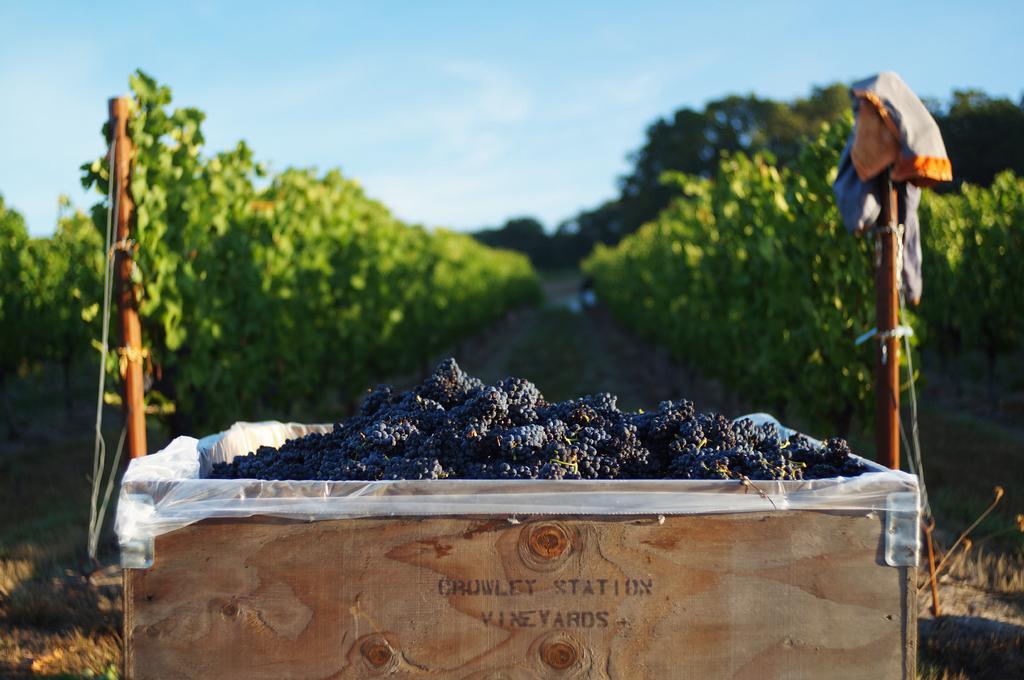Describe this image in one or two sentences. In this image we can see many grapes in a wooden box and some text is written on it, behind it there are two rods and in the background there trees and plants. 